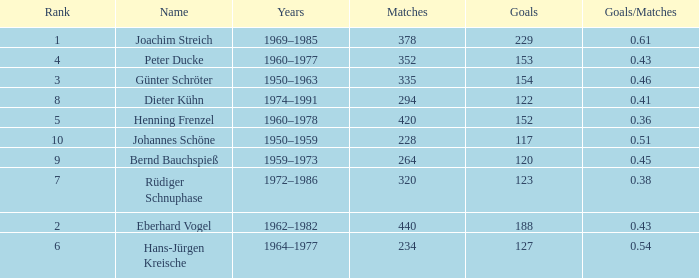How many goals/matches have 153 as the goals with matches greater than 352? None. 